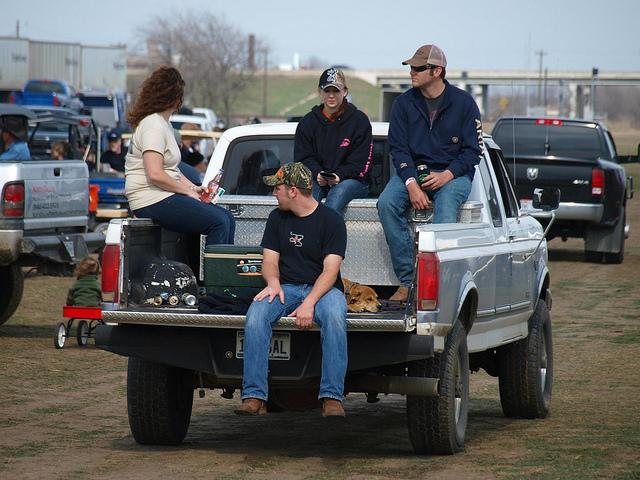What is the name for this sort of event?

Choices:
A) fight
B) tailgate
C) stakeout
D) drive tailgate 